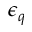Convert formula to latex. <formula><loc_0><loc_0><loc_500><loc_500>\epsilon _ { q }</formula> 